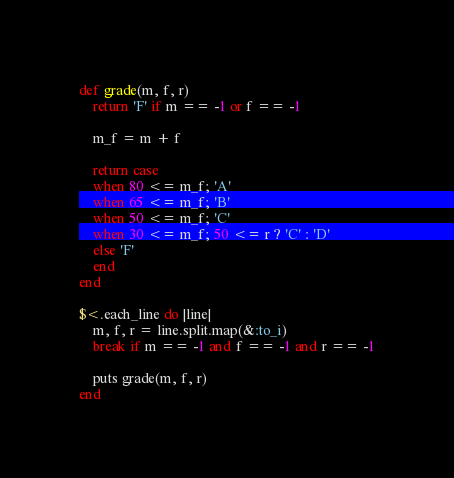<code> <loc_0><loc_0><loc_500><loc_500><_Ruby_>def grade(m, f, r)
	return 'F' if m == -1 or f == -1

	m_f = m + f

	return case
	when 80 <= m_f; 'A'
	when 65 <= m_f; 'B'
	when 50 <= m_f; 'C'
	when 30 <= m_f; 50 <= r ? 'C' : 'D'
	else 'F'
	end
end

$<.each_line do |line|
	m, f, r = line.split.map(&:to_i)
	break if m == -1 and f == -1 and r == -1

	puts grade(m, f, r)
end</code> 